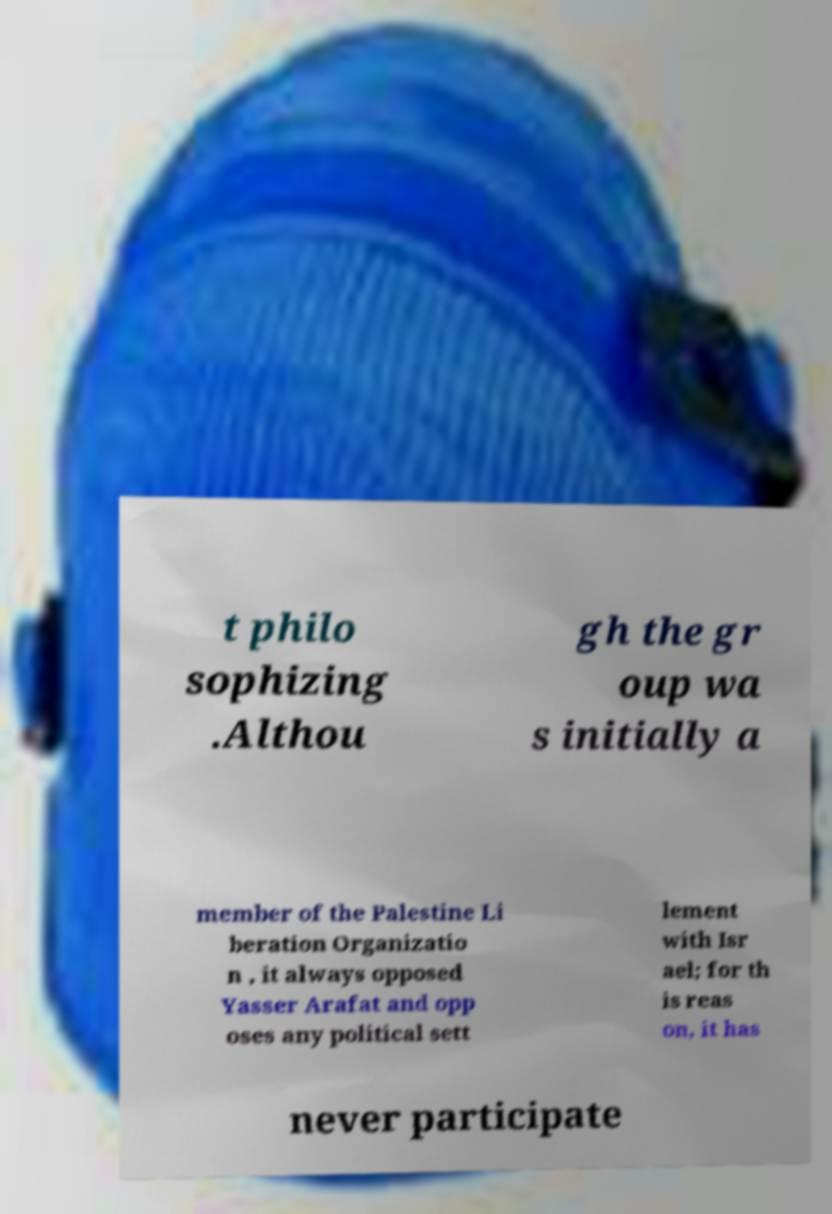What messages or text are displayed in this image? I need them in a readable, typed format. t philo sophizing .Althou gh the gr oup wa s initially a member of the Palestine Li beration Organizatio n , it always opposed Yasser Arafat and opp oses any political sett lement with Isr ael; for th is reas on, it has never participate 